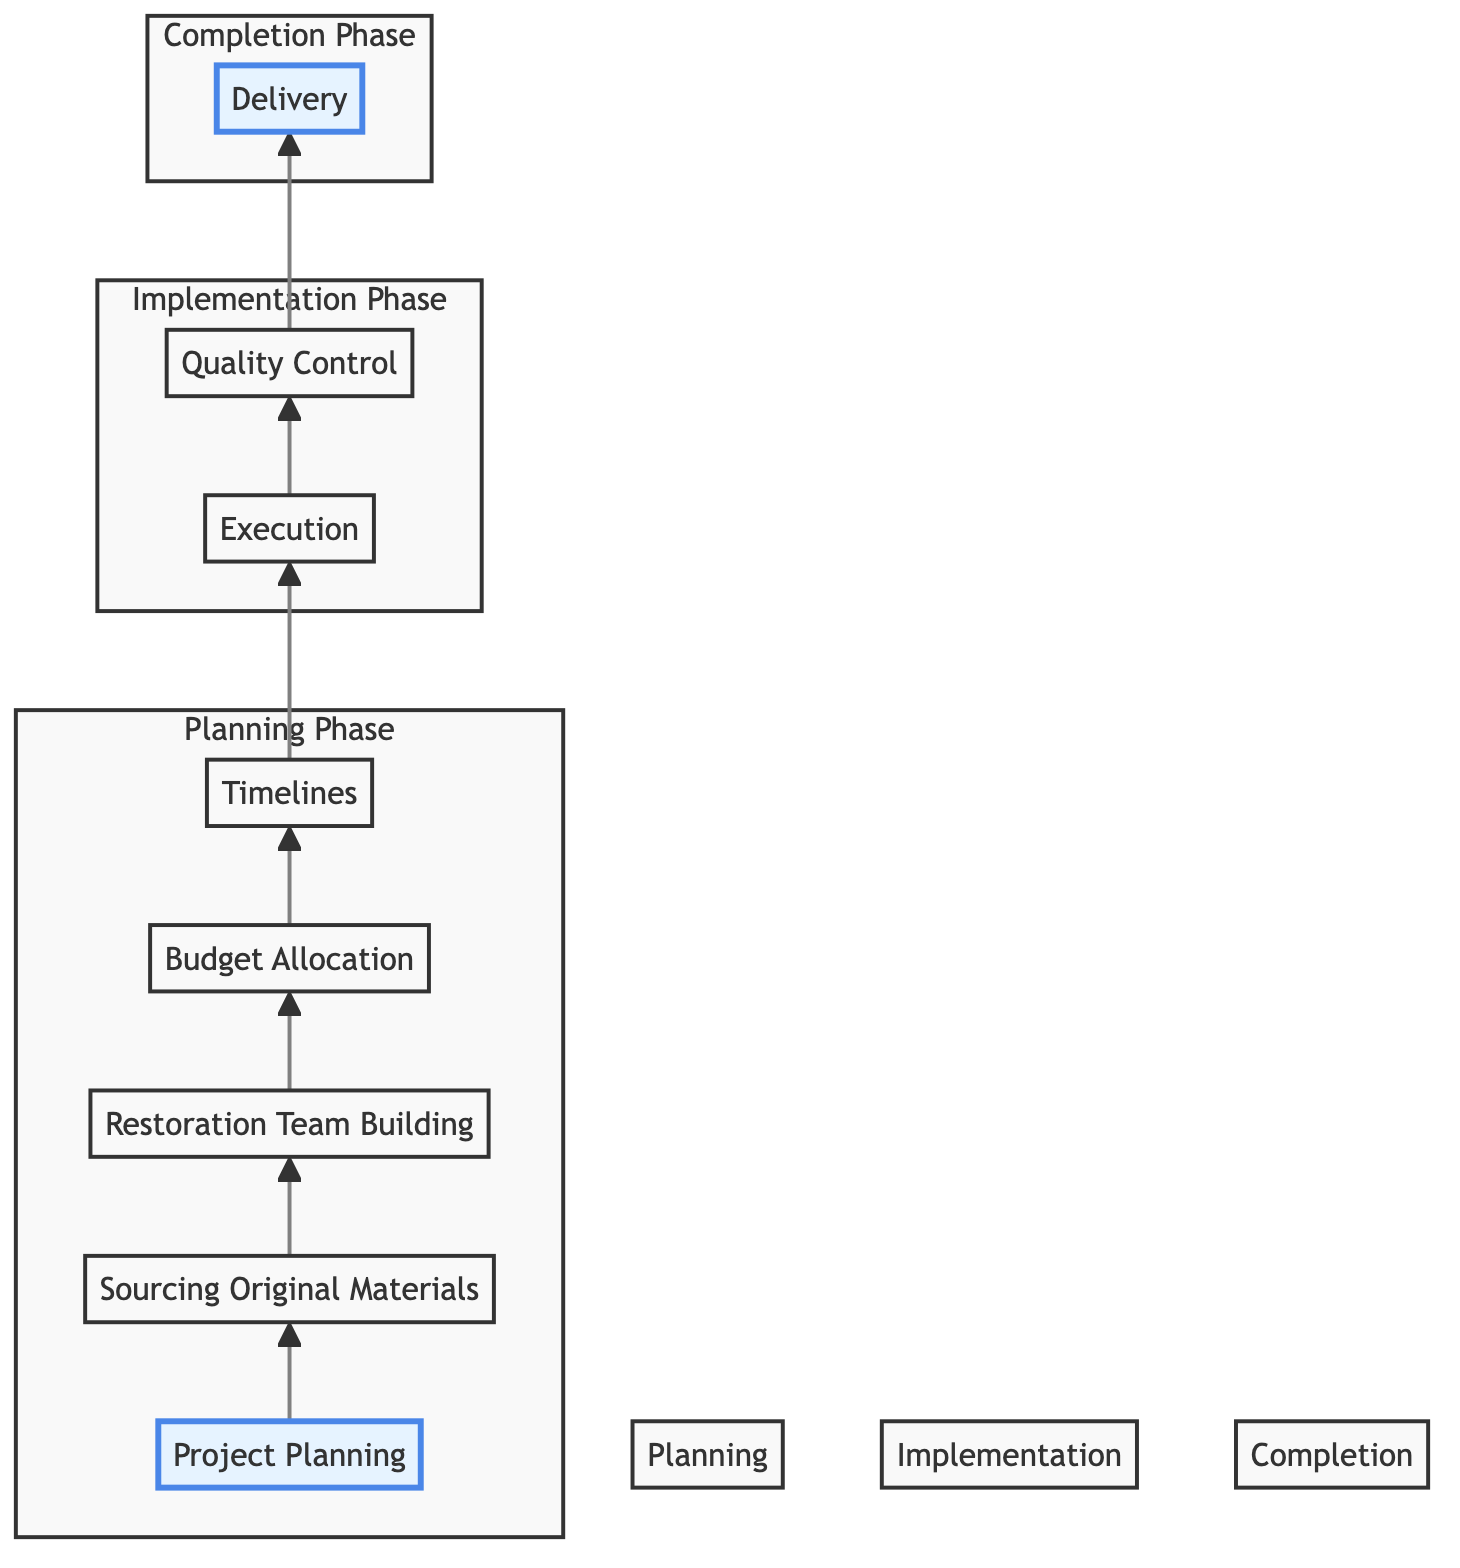What are the final steps before delivery in the workflow? In the flowchart, the steps that directly lead to delivery are Quality Control followed by Delivery itself. Therefore, the last step before delivery is Quality Control.
Answer: Quality Control How many phases are shown in the diagram? The diagram is divided into three distinct phases: Planning Phase, Implementation Phase, and Completion Phase. Thus, there are three phases.
Answer: Three Which step involves setting realistic deadlines? The step that focuses on setting realistic deadlines is Timelines, which is presented as connected to Budget Allocation and Execution.
Answer: Timelines What is the first step in the workflow? The first step in the workflow, as indicated by the bottom node, is Project Planning, which sets the scope and objectives for the restoration project.
Answer: Project Planning What must be ensured during the Quality Control step? During the Quality Control step, the high quality of the restoration work must be ensured, which involves specific checks outlined in the details.
Answer: High quality How does the Budget Allocation relate to the Timelines? Budget Allocation is a preceding step directly connected to Timelines in the workflow. This indicates that the budget is allocated before setting realistic deadlines for the project phases.
Answer: Preceding step Which step comes after the Execution phase? Following the Execution phase in the workflow is the Quality Control step. This sequence indicates that after executing restoration techniques, the quality of the work is assessed.
Answer: Quality Control What is necessary during the Restoration Team Building step? During the Restoration Team Building step, it is necessary to identify required skill sets and hire specialized personnel, which indicates the need for expertise in film restoration.
Answer: Identify skill sets What are the crucial details to collect in the Sourcing Original Materials step? In the Sourcing Original Materials step, crucial details include locating original negatives and collecting associated media like audio reels and photographs, along with verifying authenticity.
Answer: Locate original negatives 